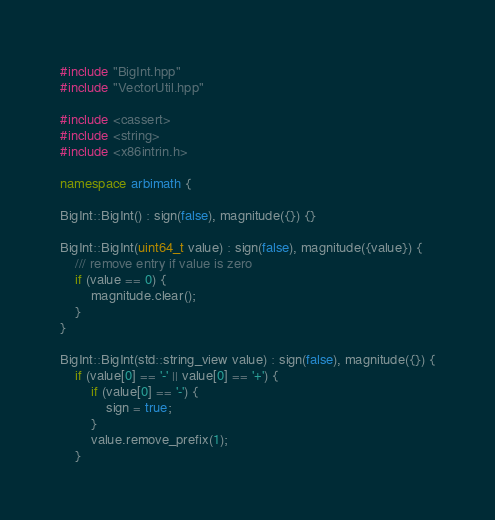Convert code to text. <code><loc_0><loc_0><loc_500><loc_500><_C++_>#include "BigInt.hpp"
#include "VectorUtil.hpp"

#include <cassert>
#include <string>
#include <x86intrin.h>

namespace arbimath {

BigInt::BigInt() : sign(false), magnitude({}) {}

BigInt::BigInt(uint64_t value) : sign(false), magnitude({value}) {
    /// remove entry if value is zero
    if (value == 0) {
        magnitude.clear();
    }
}

BigInt::BigInt(std::string_view value) : sign(false), magnitude({}) {
    if (value[0] == '-' || value[0] == '+') {
        if (value[0] == '-') {
            sign = true;
        }
        value.remove_prefix(1);
    }</code> 